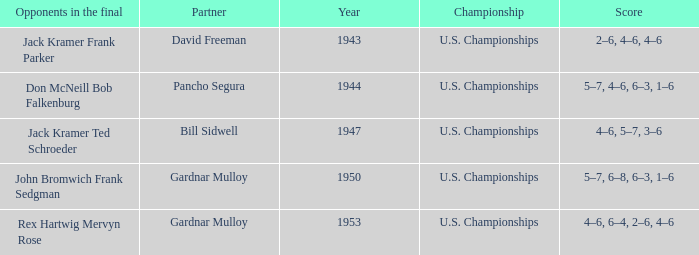Which Score has Opponents in the final of john bromwich frank sedgman? 5–7, 6–8, 6–3, 1–6. Give me the full table as a dictionary. {'header': ['Opponents in the final', 'Partner', 'Year', 'Championship', 'Score'], 'rows': [['Jack Kramer Frank Parker', 'David Freeman', '1943', 'U.S. Championships', '2–6, 4–6, 4–6'], ['Don McNeill Bob Falkenburg', 'Pancho Segura', '1944', 'U.S. Championships', '5–7, 4–6, 6–3, 1–6'], ['Jack Kramer Ted Schroeder', 'Bill Sidwell', '1947', 'U.S. Championships', '4–6, 5–7, 3–6'], ['John Bromwich Frank Sedgman', 'Gardnar Mulloy', '1950', 'U.S. Championships', '5–7, 6–8, 6–3, 1–6'], ['Rex Hartwig Mervyn Rose', 'Gardnar Mulloy', '1953', 'U.S. Championships', '4–6, 6–4, 2–6, 4–6']]} 